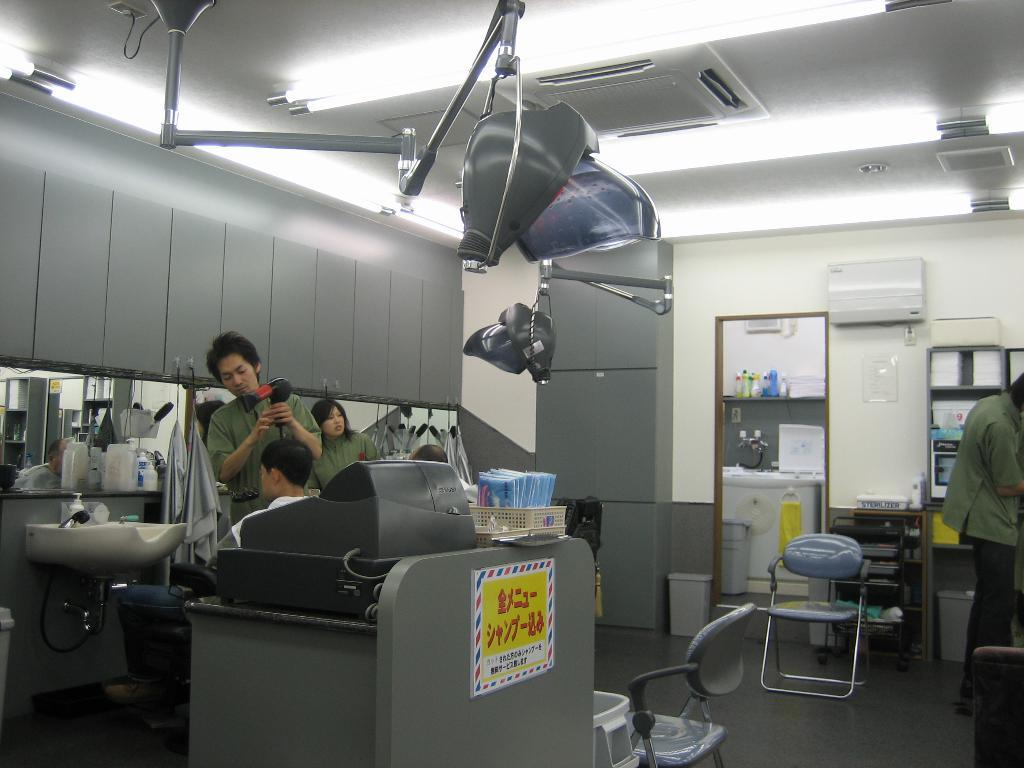How many people are in the image? There are people in the image, but the exact number is not specified. What are the people doing in the image? The people are standing in the image. What class are the people attending in the image? There is no indication of a class or any educational setting in the image. What is the people's desire in the image? There is no information about the people's desires or intentions in the image. 